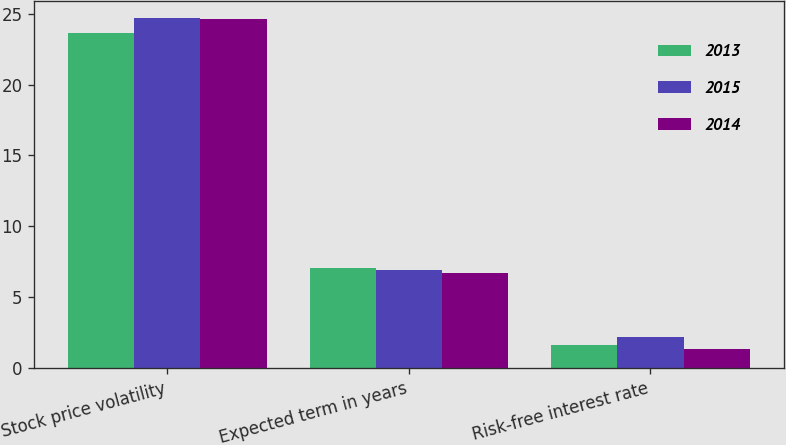<chart> <loc_0><loc_0><loc_500><loc_500><stacked_bar_chart><ecel><fcel>Stock price volatility<fcel>Expected term in years<fcel>Risk-free interest rate<nl><fcel>2013<fcel>23.62<fcel>7.06<fcel>1.59<nl><fcel>2015<fcel>24.67<fcel>6.95<fcel>2.16<nl><fcel>2014<fcel>24.61<fcel>6.69<fcel>1.31<nl></chart> 